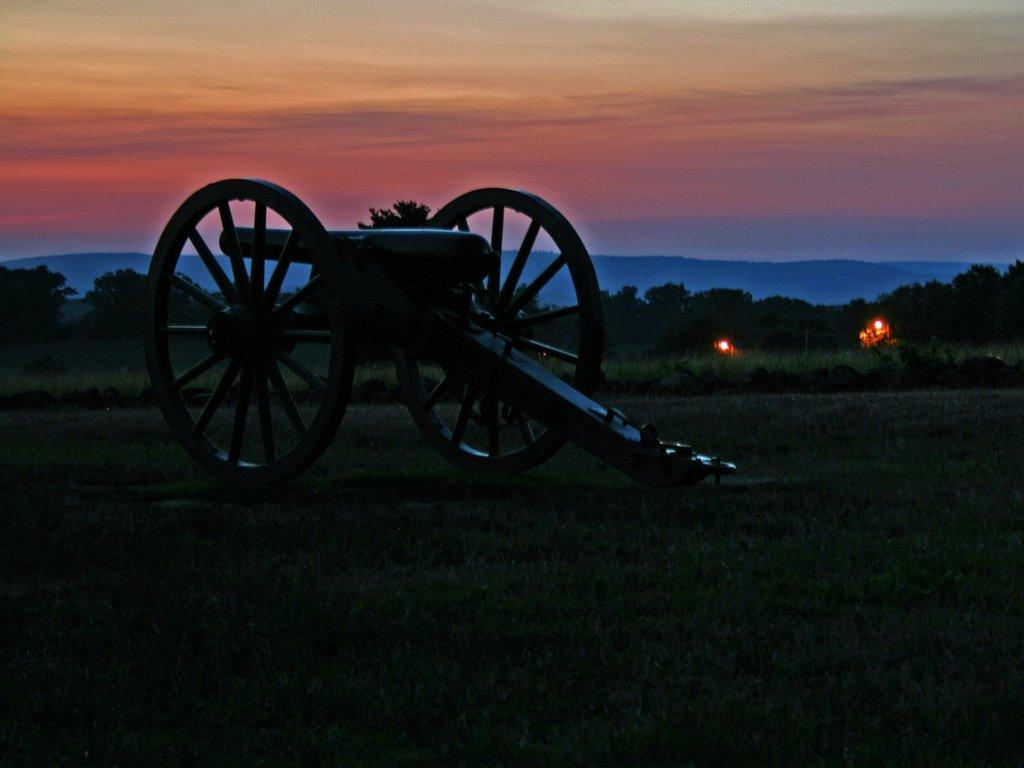What is the main subject of the image? The main subject of the image is a cannon. Where is the cannon located? The cannon is on a grassland. What can be seen in the background of the image? There are lights and trees in the background of the image. What is visible at the top of the image? The sky is visible at the top of the image. What type of rake is being used to clean the cannon in the image? There is no rake present in the image, and the cannon is not being cleaned. How is the glue being applied to the cannon in the image? There is no glue present in the image, and the cannon is not being modified or altered. 